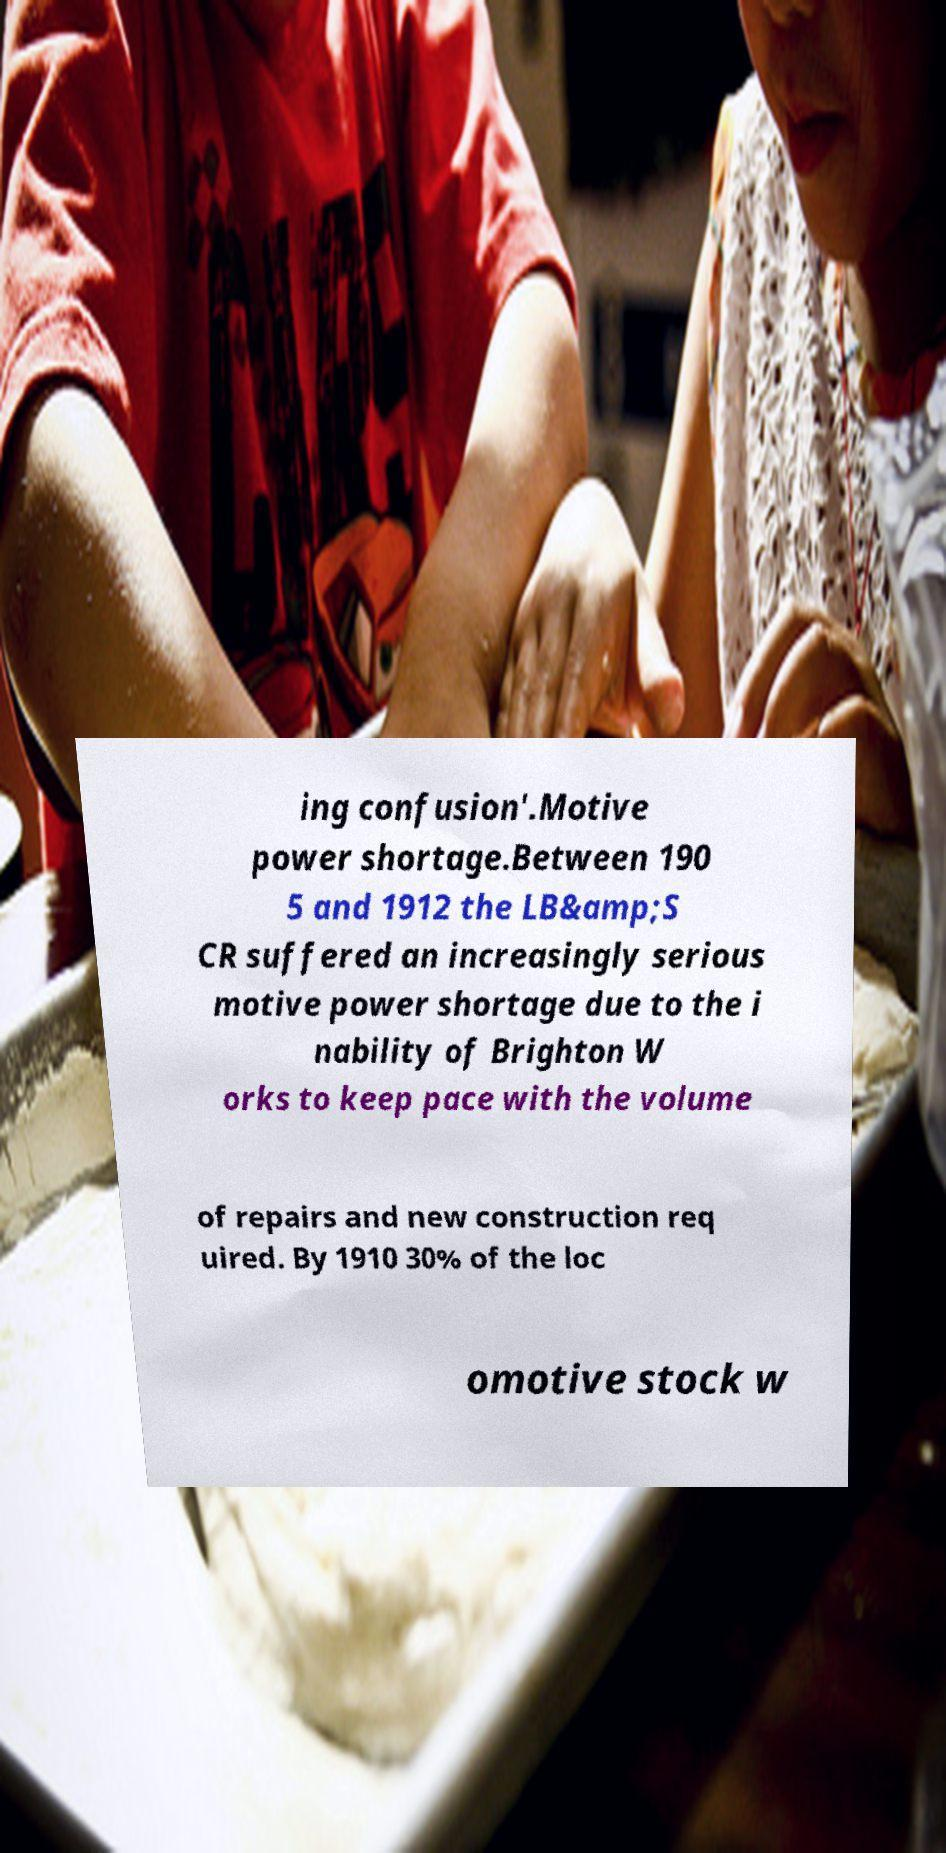Can you read and provide the text displayed in the image?This photo seems to have some interesting text. Can you extract and type it out for me? ing confusion'.Motive power shortage.Between 190 5 and 1912 the LB&amp;S CR suffered an increasingly serious motive power shortage due to the i nability of Brighton W orks to keep pace with the volume of repairs and new construction req uired. By 1910 30% of the loc omotive stock w 